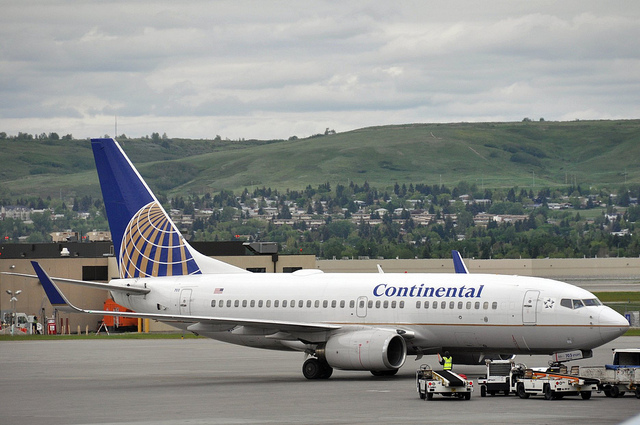Please extract the text content from this image. Continental 